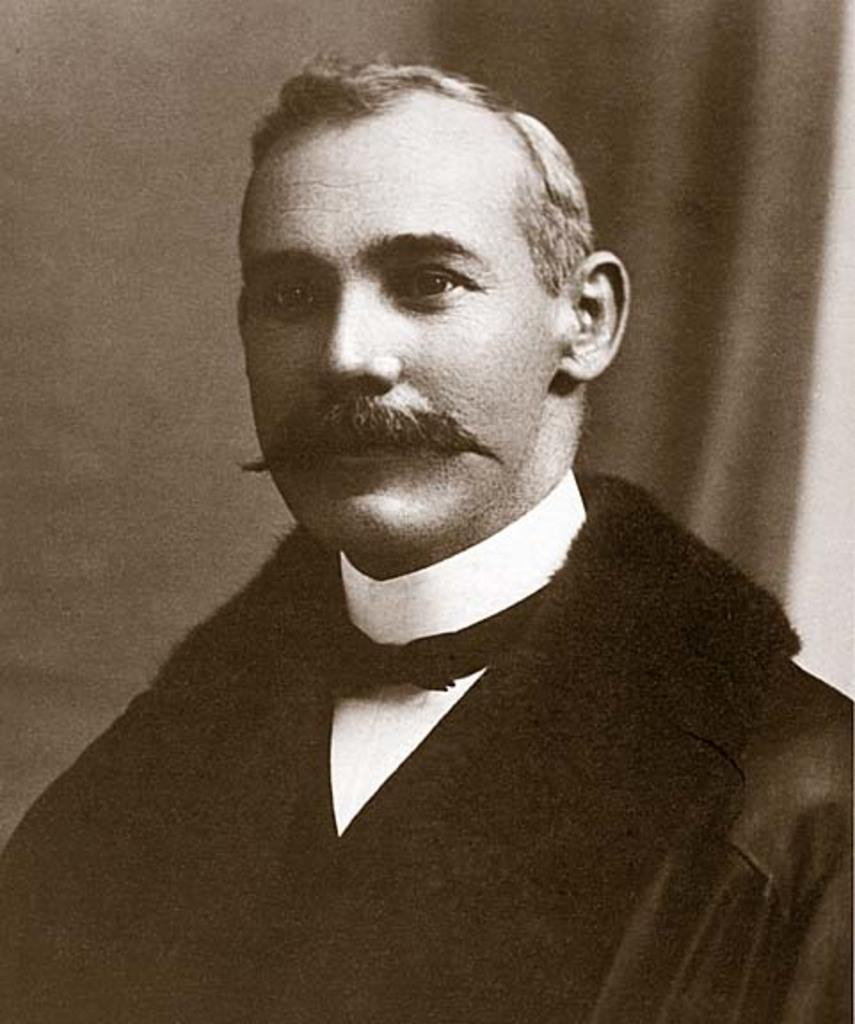What is the main subject in the foreground of the image? There is a man in the foreground of the image. What is the man wearing? The man is wearing a black dress. Can you describe the background of the image? There is an object in the background that seems to be a curtain. What type of quilt can be seen hanging on the wall in the image? There is no quilt present in the image; it only features a man in the foreground and a curtain in the background. 